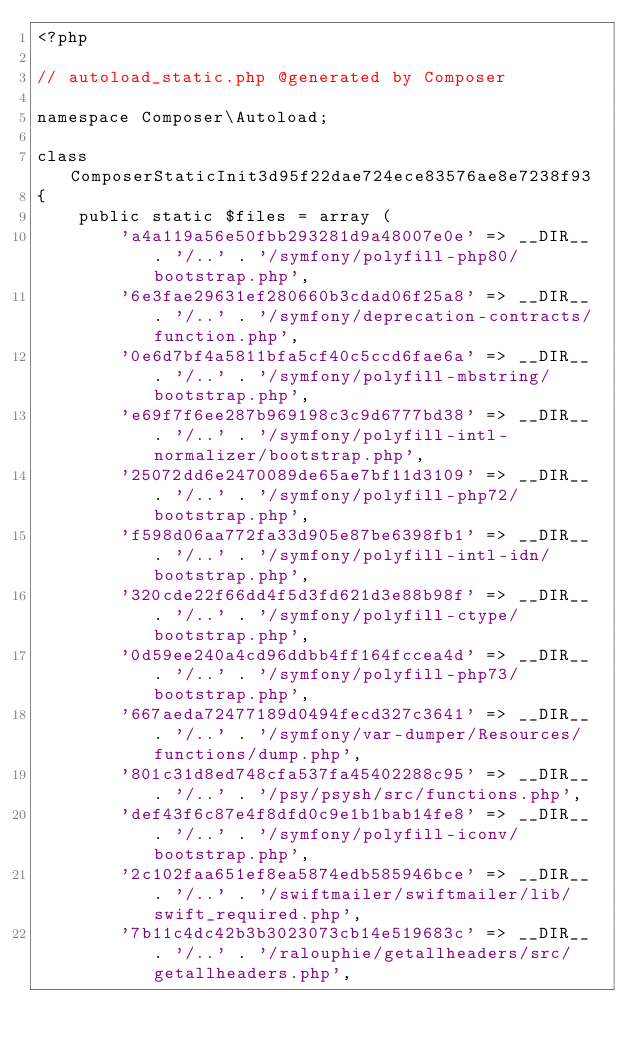Convert code to text. <code><loc_0><loc_0><loc_500><loc_500><_PHP_><?php

// autoload_static.php @generated by Composer

namespace Composer\Autoload;

class ComposerStaticInit3d95f22dae724ece83576ae8e7238f93
{
    public static $files = array (
        'a4a119a56e50fbb293281d9a48007e0e' => __DIR__ . '/..' . '/symfony/polyfill-php80/bootstrap.php',
        '6e3fae29631ef280660b3cdad06f25a8' => __DIR__ . '/..' . '/symfony/deprecation-contracts/function.php',
        '0e6d7bf4a5811bfa5cf40c5ccd6fae6a' => __DIR__ . '/..' . '/symfony/polyfill-mbstring/bootstrap.php',
        'e69f7f6ee287b969198c3c9d6777bd38' => __DIR__ . '/..' . '/symfony/polyfill-intl-normalizer/bootstrap.php',
        '25072dd6e2470089de65ae7bf11d3109' => __DIR__ . '/..' . '/symfony/polyfill-php72/bootstrap.php',
        'f598d06aa772fa33d905e87be6398fb1' => __DIR__ . '/..' . '/symfony/polyfill-intl-idn/bootstrap.php',
        '320cde22f66dd4f5d3fd621d3e88b98f' => __DIR__ . '/..' . '/symfony/polyfill-ctype/bootstrap.php',
        '0d59ee240a4cd96ddbb4ff164fccea4d' => __DIR__ . '/..' . '/symfony/polyfill-php73/bootstrap.php',
        '667aeda72477189d0494fecd327c3641' => __DIR__ . '/..' . '/symfony/var-dumper/Resources/functions/dump.php',
        '801c31d8ed748cfa537fa45402288c95' => __DIR__ . '/..' . '/psy/psysh/src/functions.php',
        'def43f6c87e4f8dfd0c9e1b1bab14fe8' => __DIR__ . '/..' . '/symfony/polyfill-iconv/bootstrap.php',
        '2c102faa651ef8ea5874edb585946bce' => __DIR__ . '/..' . '/swiftmailer/swiftmailer/lib/swift_required.php',
        '7b11c4dc42b3b3023073cb14e519683c' => __DIR__ . '/..' . '/ralouphie/getallheaders/src/getallheaders.php',</code> 